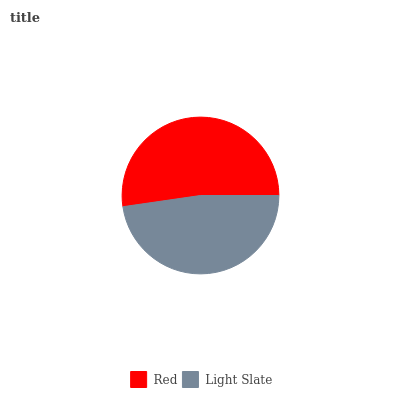Is Light Slate the minimum?
Answer yes or no. Yes. Is Red the maximum?
Answer yes or no. Yes. Is Light Slate the maximum?
Answer yes or no. No. Is Red greater than Light Slate?
Answer yes or no. Yes. Is Light Slate less than Red?
Answer yes or no. Yes. Is Light Slate greater than Red?
Answer yes or no. No. Is Red less than Light Slate?
Answer yes or no. No. Is Red the high median?
Answer yes or no. Yes. Is Light Slate the low median?
Answer yes or no. Yes. Is Light Slate the high median?
Answer yes or no. No. Is Red the low median?
Answer yes or no. No. 